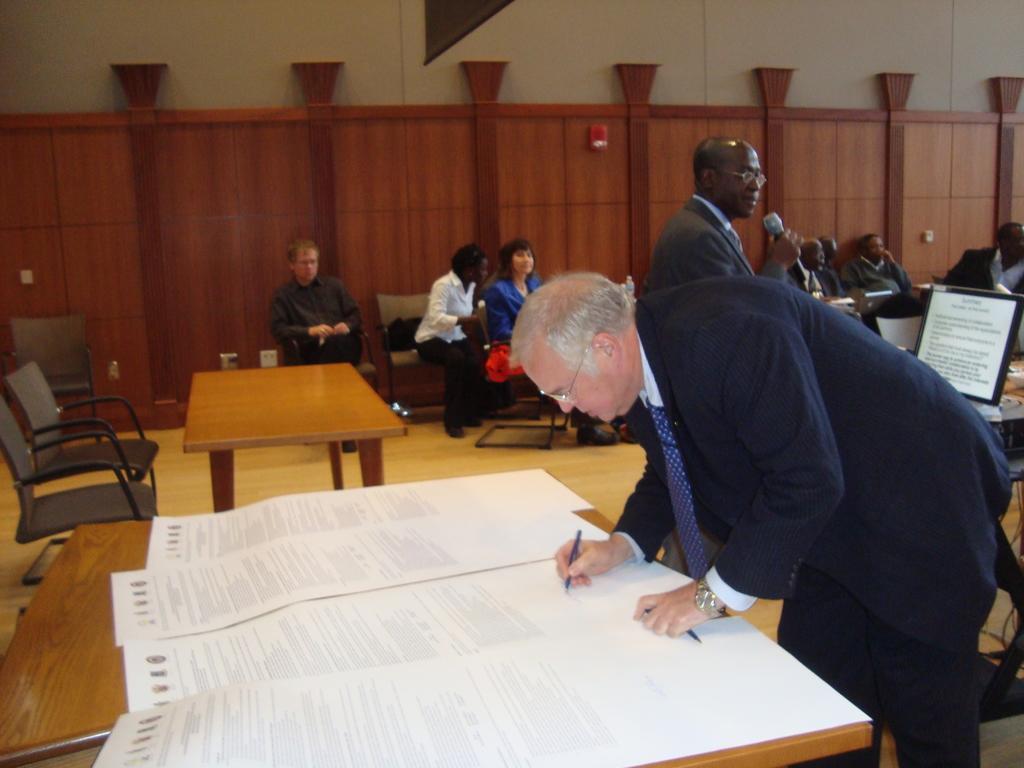Could you give a brief overview of what you see in this image? The person wearing suit is writing something on a paper placed on a table and there are group of people behind him. 